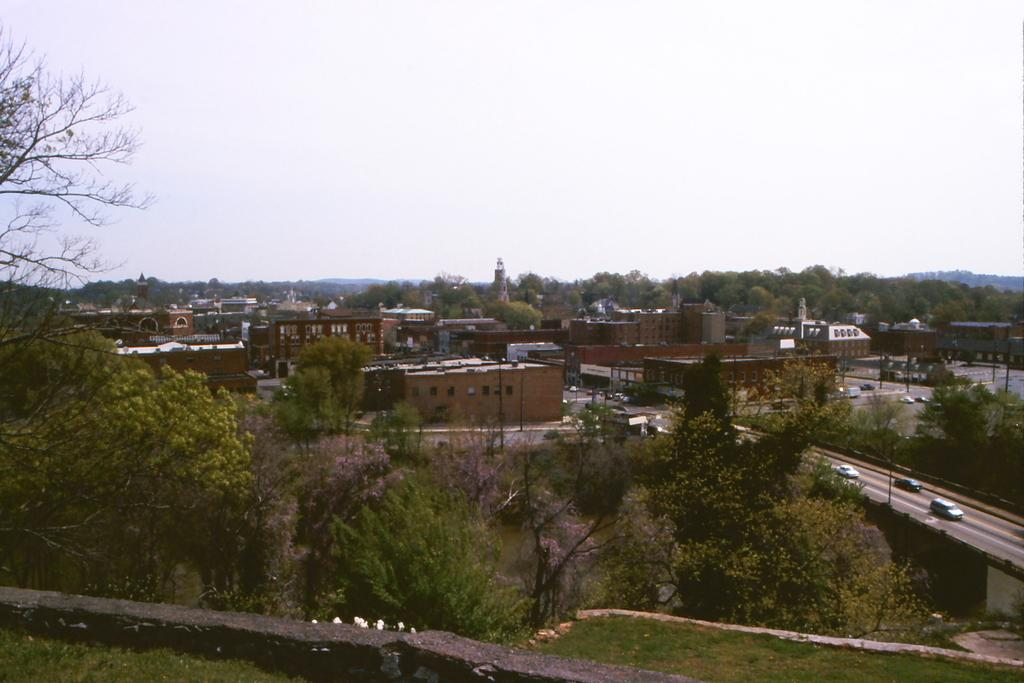What type of location is depicted in the image? The image is of a city. What structures can be seen in the city? There are buildings in the image. Are there any natural elements present in the city? Yes, there are trees in the image. What type of infrastructure is visible in the image? There are poles and roads in the image. What type of transportation can be seen in the city? There are vehicles in the image. What part of the natural environment is visible in the image? The sky is visible in the image. What type of arithmetic problem is being solved by the sheep in the image? There are no sheep present in the image, and therefore no arithmetic problem is being solved. What type of wine is being served at the restaurant in the image? There is no restaurant or wine present in the image. 